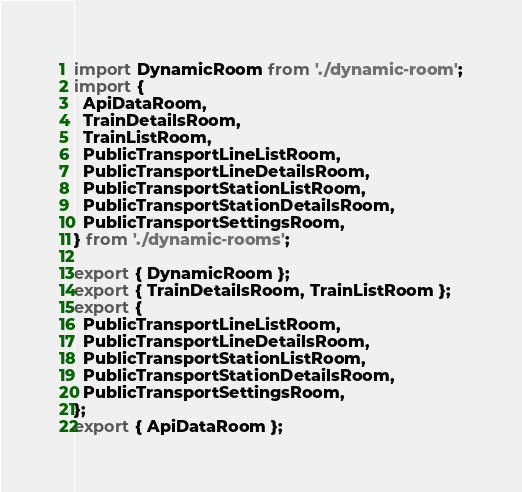Convert code to text. <code><loc_0><loc_0><loc_500><loc_500><_TypeScript_>import DynamicRoom from './dynamic-room';
import {
  ApiDataRoom,
  TrainDetailsRoom,
  TrainListRoom,
  PublicTransportLineListRoom,
  PublicTransportLineDetailsRoom,
  PublicTransportStationListRoom,
  PublicTransportStationDetailsRoom,
  PublicTransportSettingsRoom,
} from './dynamic-rooms';

export { DynamicRoom };
export { TrainDetailsRoom, TrainListRoom };
export {
  PublicTransportLineListRoom,
  PublicTransportLineDetailsRoom,
  PublicTransportStationListRoom,
  PublicTransportStationDetailsRoom,
  PublicTransportSettingsRoom,
};
export { ApiDataRoom };
</code> 